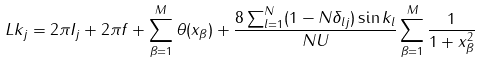Convert formula to latex. <formula><loc_0><loc_0><loc_500><loc_500>L k _ { j } = 2 \pi I _ { j } + 2 \pi f + \sum ^ { M } _ { \beta = 1 } \theta ( x _ { \beta } ) + \frac { 8 \sum ^ { N } _ { l = 1 } ( 1 - N \delta _ { l j } ) \sin k _ { l } } { N U } \sum ^ { M } _ { \beta = 1 } \frac { 1 } { 1 + x ^ { 2 } _ { \beta } }</formula> 